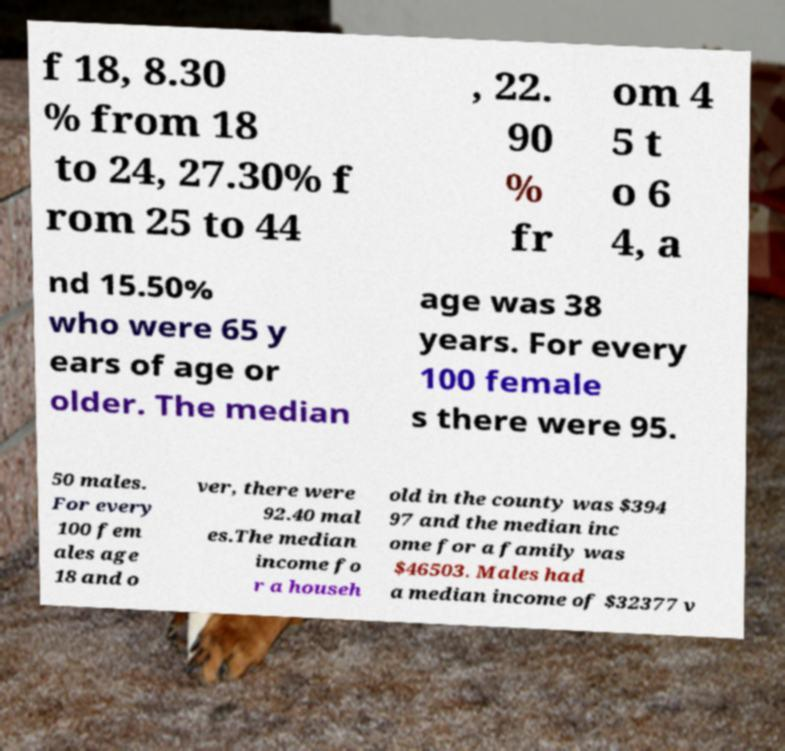I need the written content from this picture converted into text. Can you do that? f 18, 8.30 % from 18 to 24, 27.30% f rom 25 to 44 , 22. 90 % fr om 4 5 t o 6 4, a nd 15.50% who were 65 y ears of age or older. The median age was 38 years. For every 100 female s there were 95. 50 males. For every 100 fem ales age 18 and o ver, there were 92.40 mal es.The median income fo r a househ old in the county was $394 97 and the median inc ome for a family was $46503. Males had a median income of $32377 v 